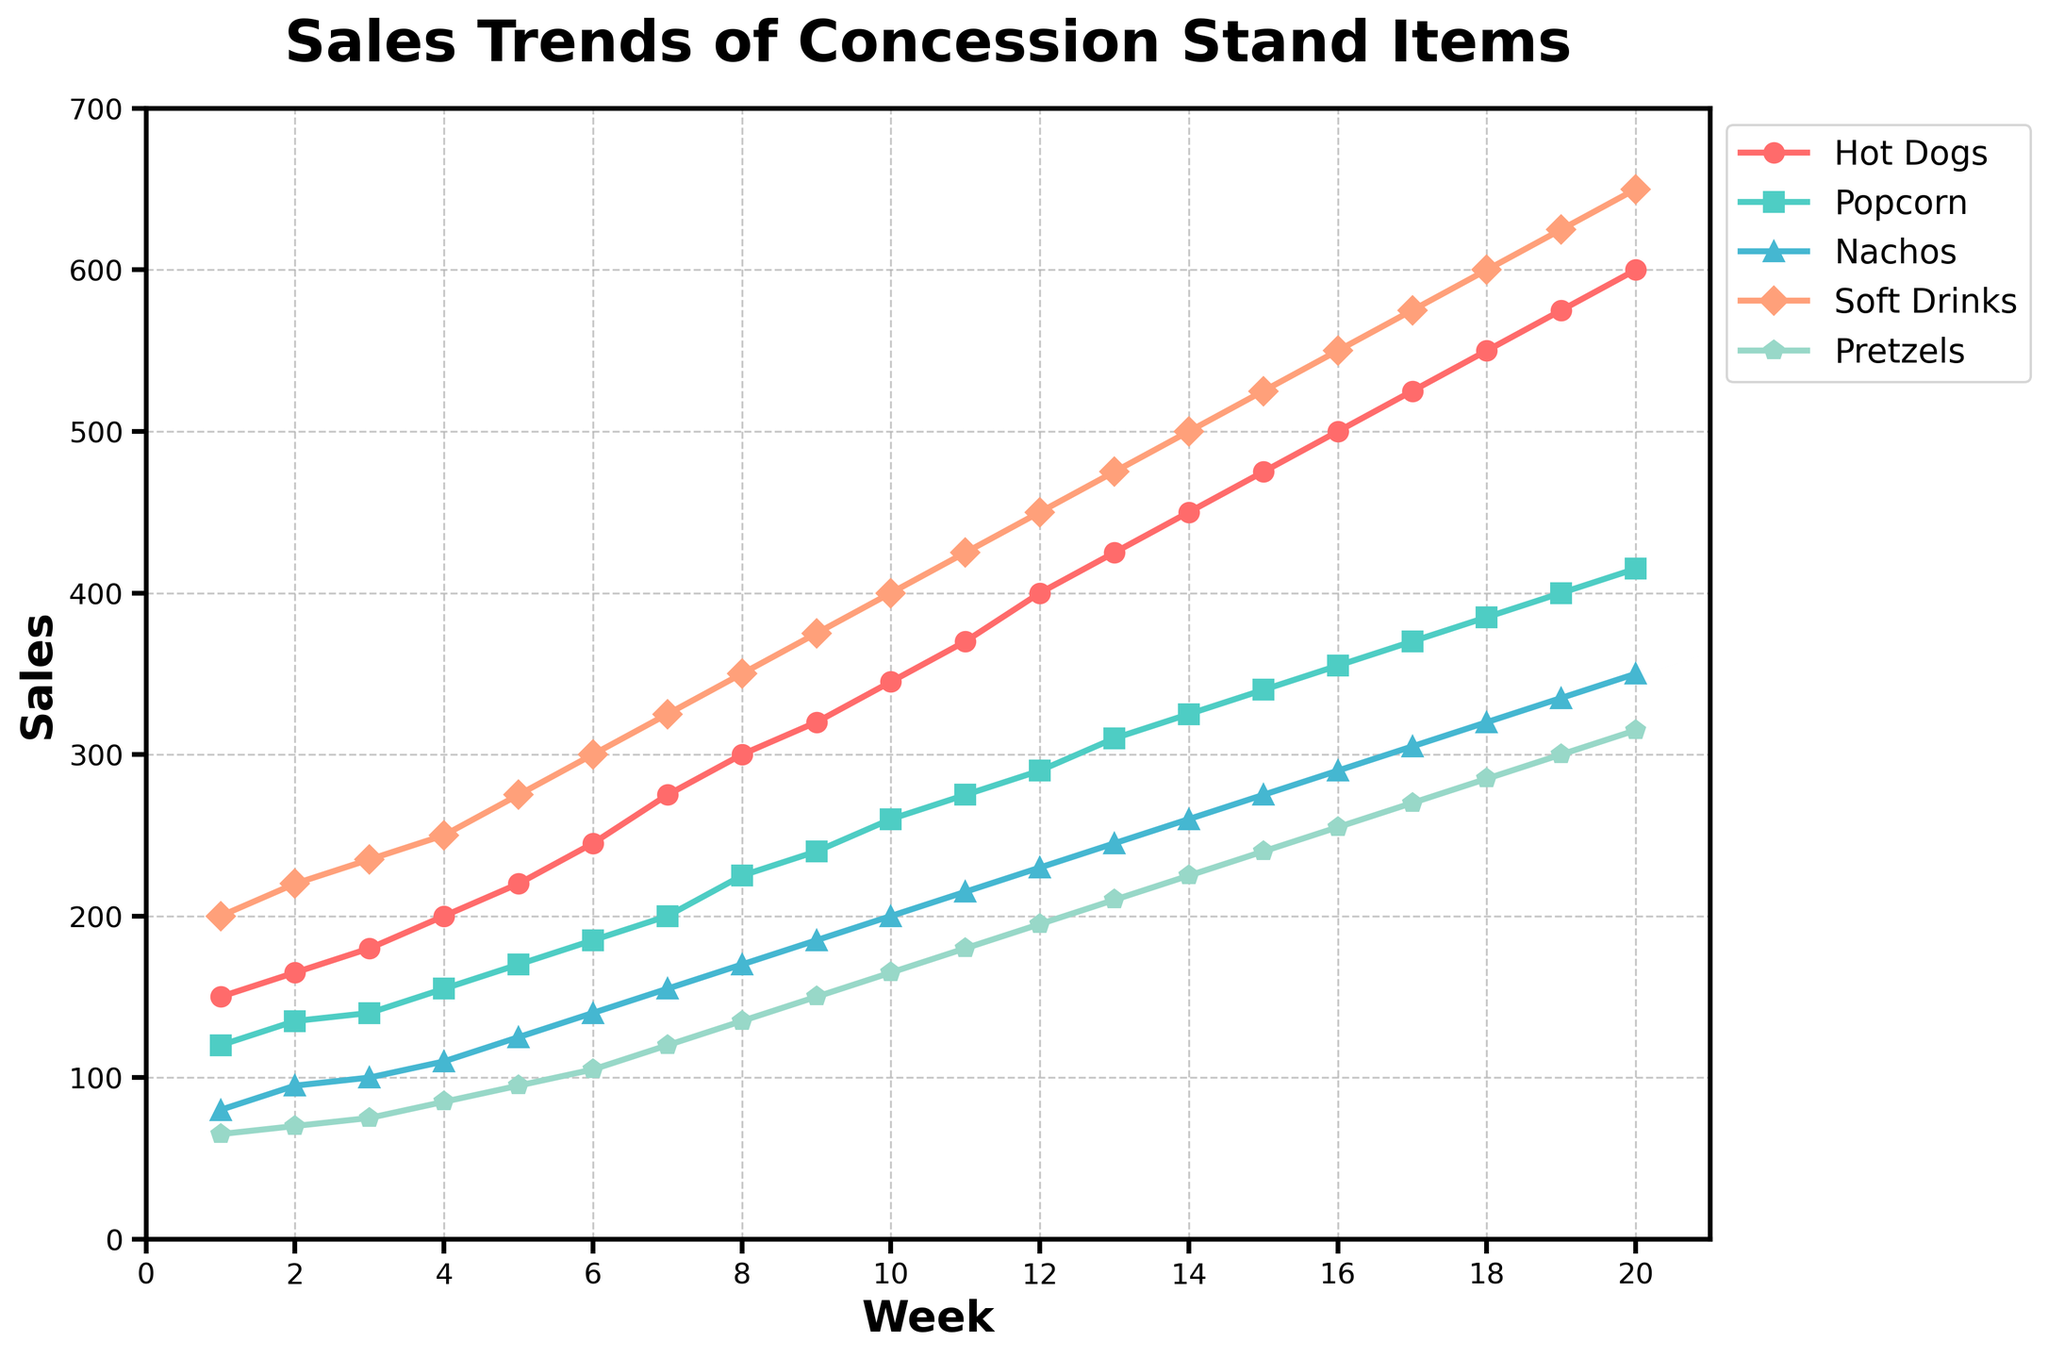Which concession item had the highest sales in Week 10? Look at the data points for Week 10 and compare the sales of each item. The Soft Drinks have the highest sales.
Answer: Soft Drinks What is the total sales of Hot Dogs and Nachos combined for Week 5? Look at the sales for both Hot Dogs and Nachos for Week 5 and add them up. Sales for Hot Dogs = 220 and Nachos = 125. Total = 220 + 125 = 345.
Answer: 345 Which item showed the largest increase in sales from Week 1 to Week 20? Compare the difference in sales from Week 1 to Week 20 for each item. Hot Dogs increased from 150 to 600, Popcorn from 120 to 415, Nachos from 80 to 350, Soft Drinks from 200 to 650, and Pretzels from 65 to 315. The largest increase is for Soft Drinks (650 - 200 = 450).
Answer: Soft Drinks In which week did Pretzels first reach 100 sales? Identify the week where Pretzels sales first equal or exceed 100. This first happens in Week 6 where Pretzels reach 105 sales.
Answer: Week 6 Which item had the least sales in Week 15? Compare the sales of all the items in Week 15. Pretzels had the least sales with 240.
Answer: Pretzels What is the average sales of Popcorn over the 20 weeks? Sum all the weekly sales for Popcorn and then divide by 20. The sales are 120+135+140+155+170+185+200+225+240+260+275+290+310+325+340+355+370+385+400+415 = 5710, and the average is 5710/20 = 285.5.
Answer: 285.5 By how much did Nachos sales increase from Week 3 to Week 12? Subtract the sales of Nachos in Week 3 from the sales in Week 12. Sales in Week 3 = 100 and in Week 12 = 230. So, 230 - 100 = 130.
Answer: 130 If the sales trend continues, what would you expect the Pretzels sales to be in Week 21? Look at the trend of Pretzels sales and project it forwards. Pretzels increase by 15 every week. Sales in Week 20 = 315, so in Week 21 it would be 315 + 15 = 330.
Answer: 330 Which weeks show a sales spike for Popcorn and what could be the reason? Identify weeks with significant increases in Popcorn sales. Notable spikes are seen from Week 7 (200) to Week 8 (225), Week 11 (275) to Week 12 (290), and Week 14 (325) to Week 15 (340). Reasons might include promotions or events.
Answer: Weeks 7-8, Weeks 11-12, Weeks 14-15 What is the combined sales of all items in Week 18? Add up the sales of all items in Week 18. Sales in Week 18 = Hot Dogs: 550, Popcorn: 385, Nachos: 320, Soft Drinks: 600, Pretzels: 285. Total = 550 + 385 + 320 + 600 + 285 = 2140.
Answer: 2140 